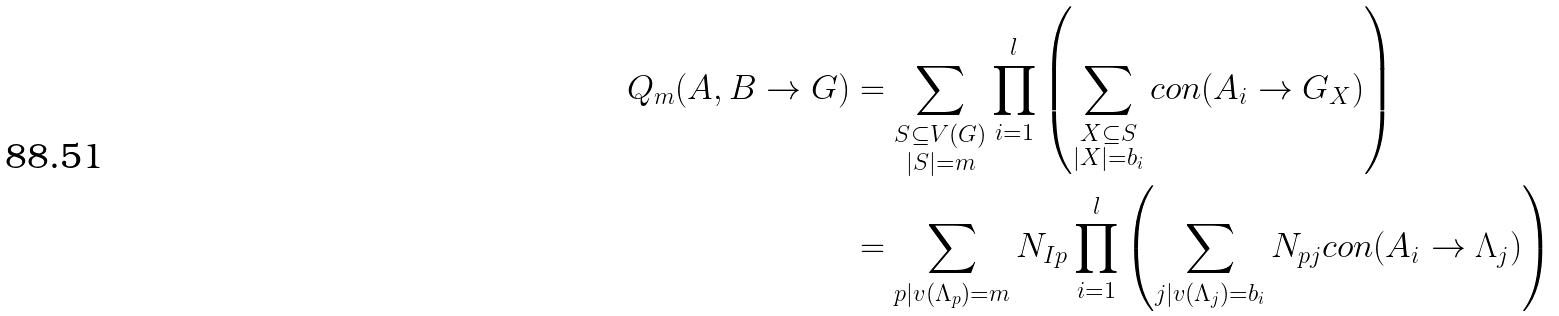<formula> <loc_0><loc_0><loc_500><loc_500>Q _ { m } ( A , B \rightarrow G ) & = \sum _ { \substack { S \subseteq V ( G ) \\ | S | = m } } \prod _ { i = 1 } ^ { l } \left ( \sum _ { \substack { X \subseteq S \\ | X | = b _ { i } } } c o n ( A _ { i } \rightarrow G _ { X } ) \right ) \\ & = \sum _ { p | v ( \Lambda _ { p } ) = m } N _ { I p } \prod _ { i = 1 } ^ { l } \left ( \sum _ { j | v ( \Lambda _ { j } ) = b _ { i } } N _ { p j } c o n ( A _ { i } \rightarrow \Lambda _ { j } ) \right )</formula> 